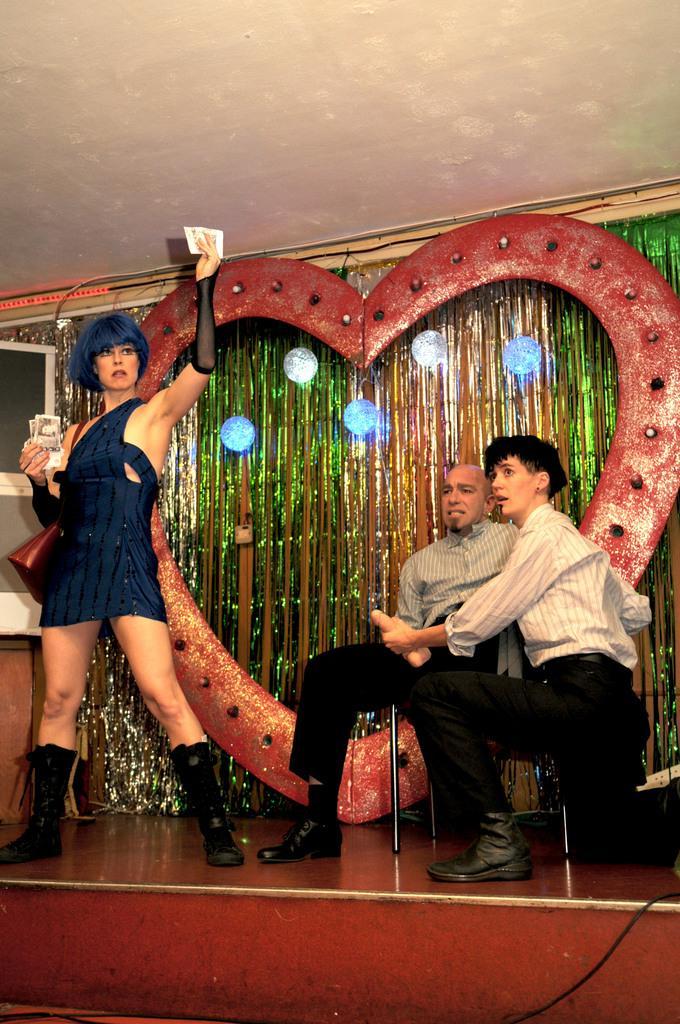In one or two sentences, can you explain what this image depicts? This picture describes about group of people, in the left side of the image we can see a woman, she is holding papers, beside to her we can find a man he is seated on the chair, in the background we can find few lights. 